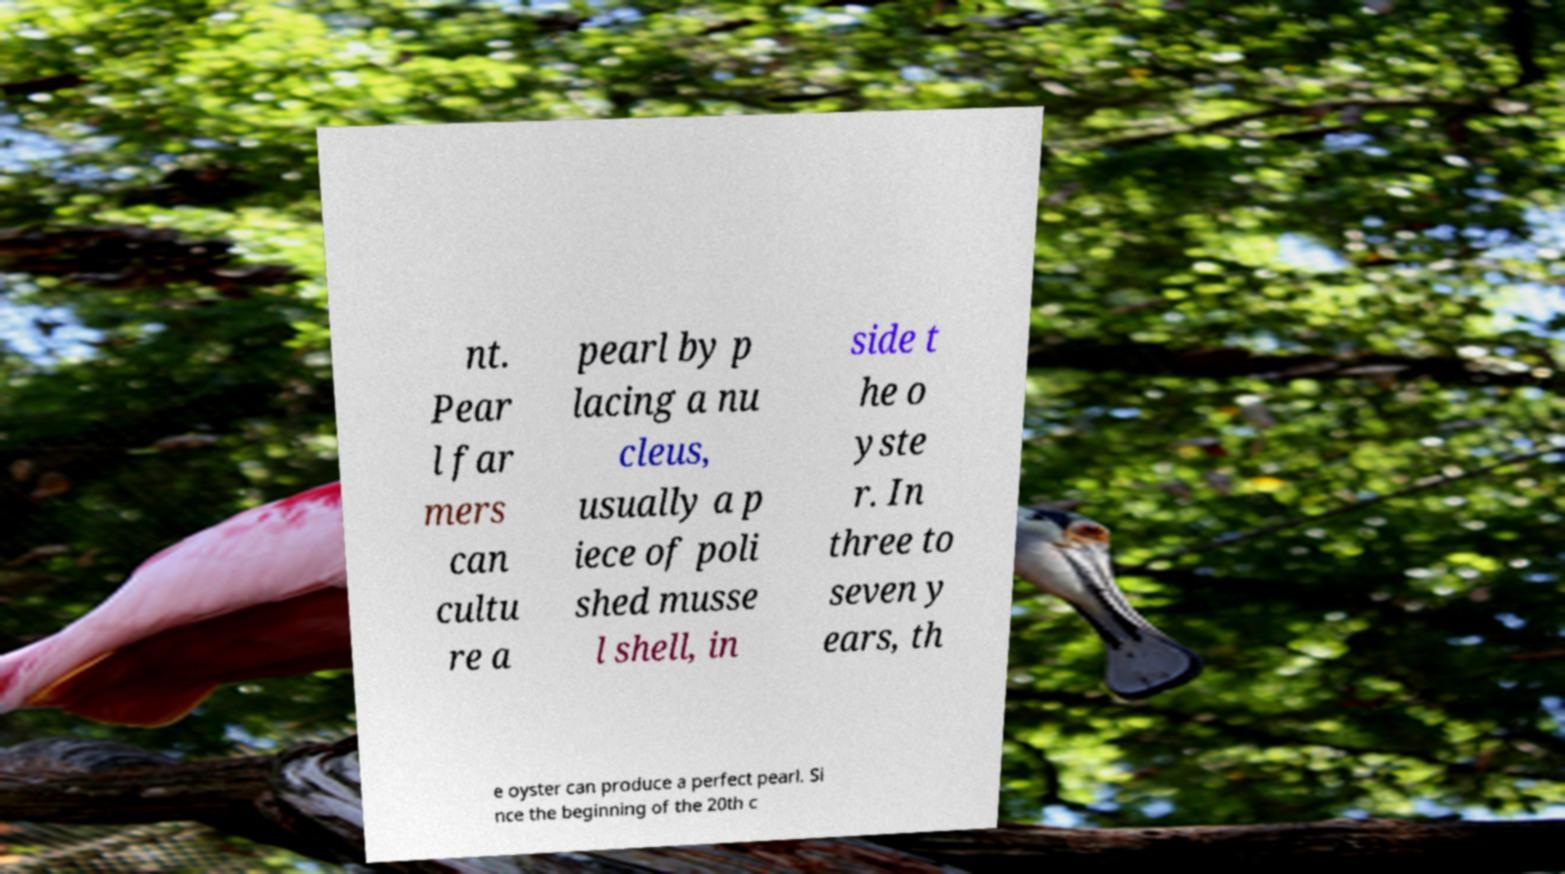Please identify and transcribe the text found in this image. nt. Pear l far mers can cultu re a pearl by p lacing a nu cleus, usually a p iece of poli shed musse l shell, in side t he o yste r. In three to seven y ears, th e oyster can produce a perfect pearl. Si nce the beginning of the 20th c 